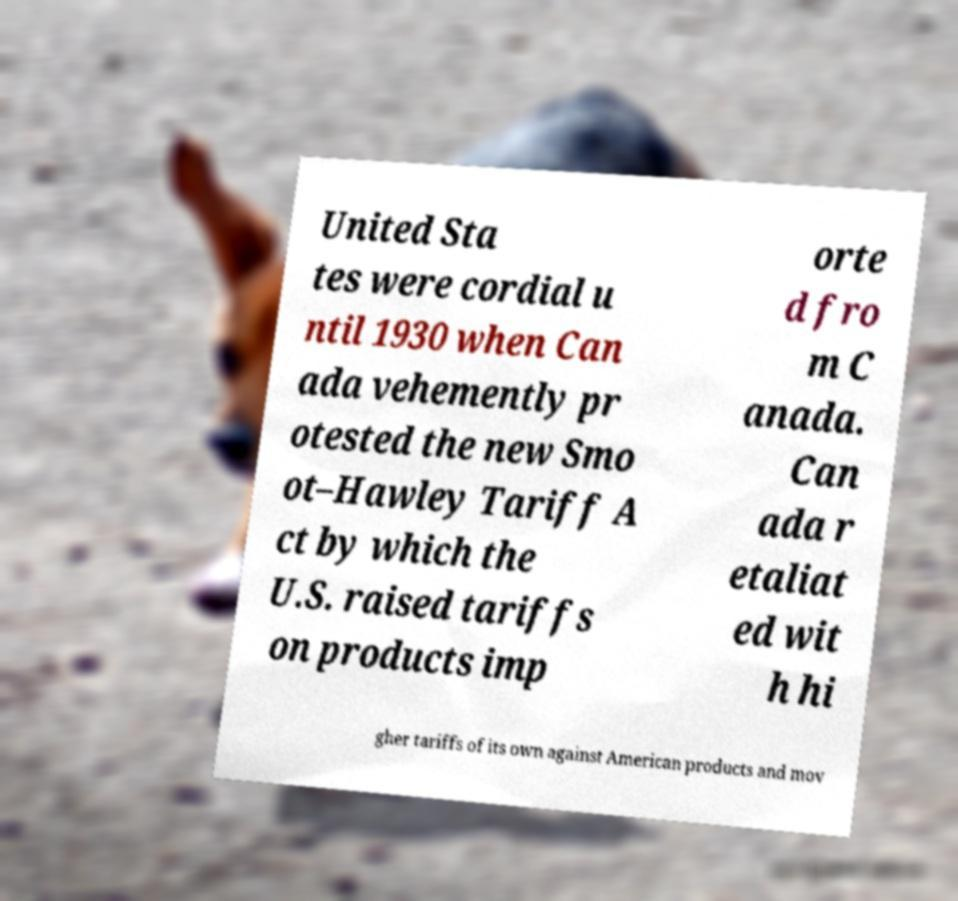Please identify and transcribe the text found in this image. United Sta tes were cordial u ntil 1930 when Can ada vehemently pr otested the new Smo ot–Hawley Tariff A ct by which the U.S. raised tariffs on products imp orte d fro m C anada. Can ada r etaliat ed wit h hi gher tariffs of its own against American products and mov 